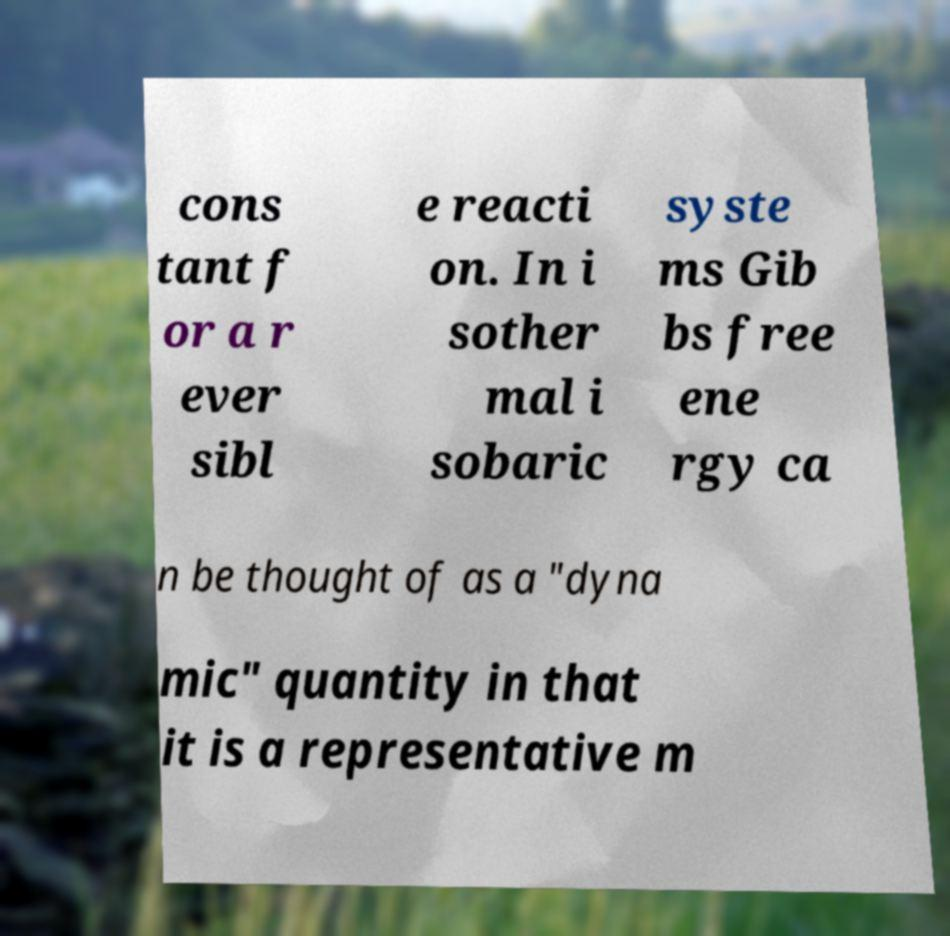Can you read and provide the text displayed in the image?This photo seems to have some interesting text. Can you extract and type it out for me? cons tant f or a r ever sibl e reacti on. In i sother mal i sobaric syste ms Gib bs free ene rgy ca n be thought of as a "dyna mic" quantity in that it is a representative m 